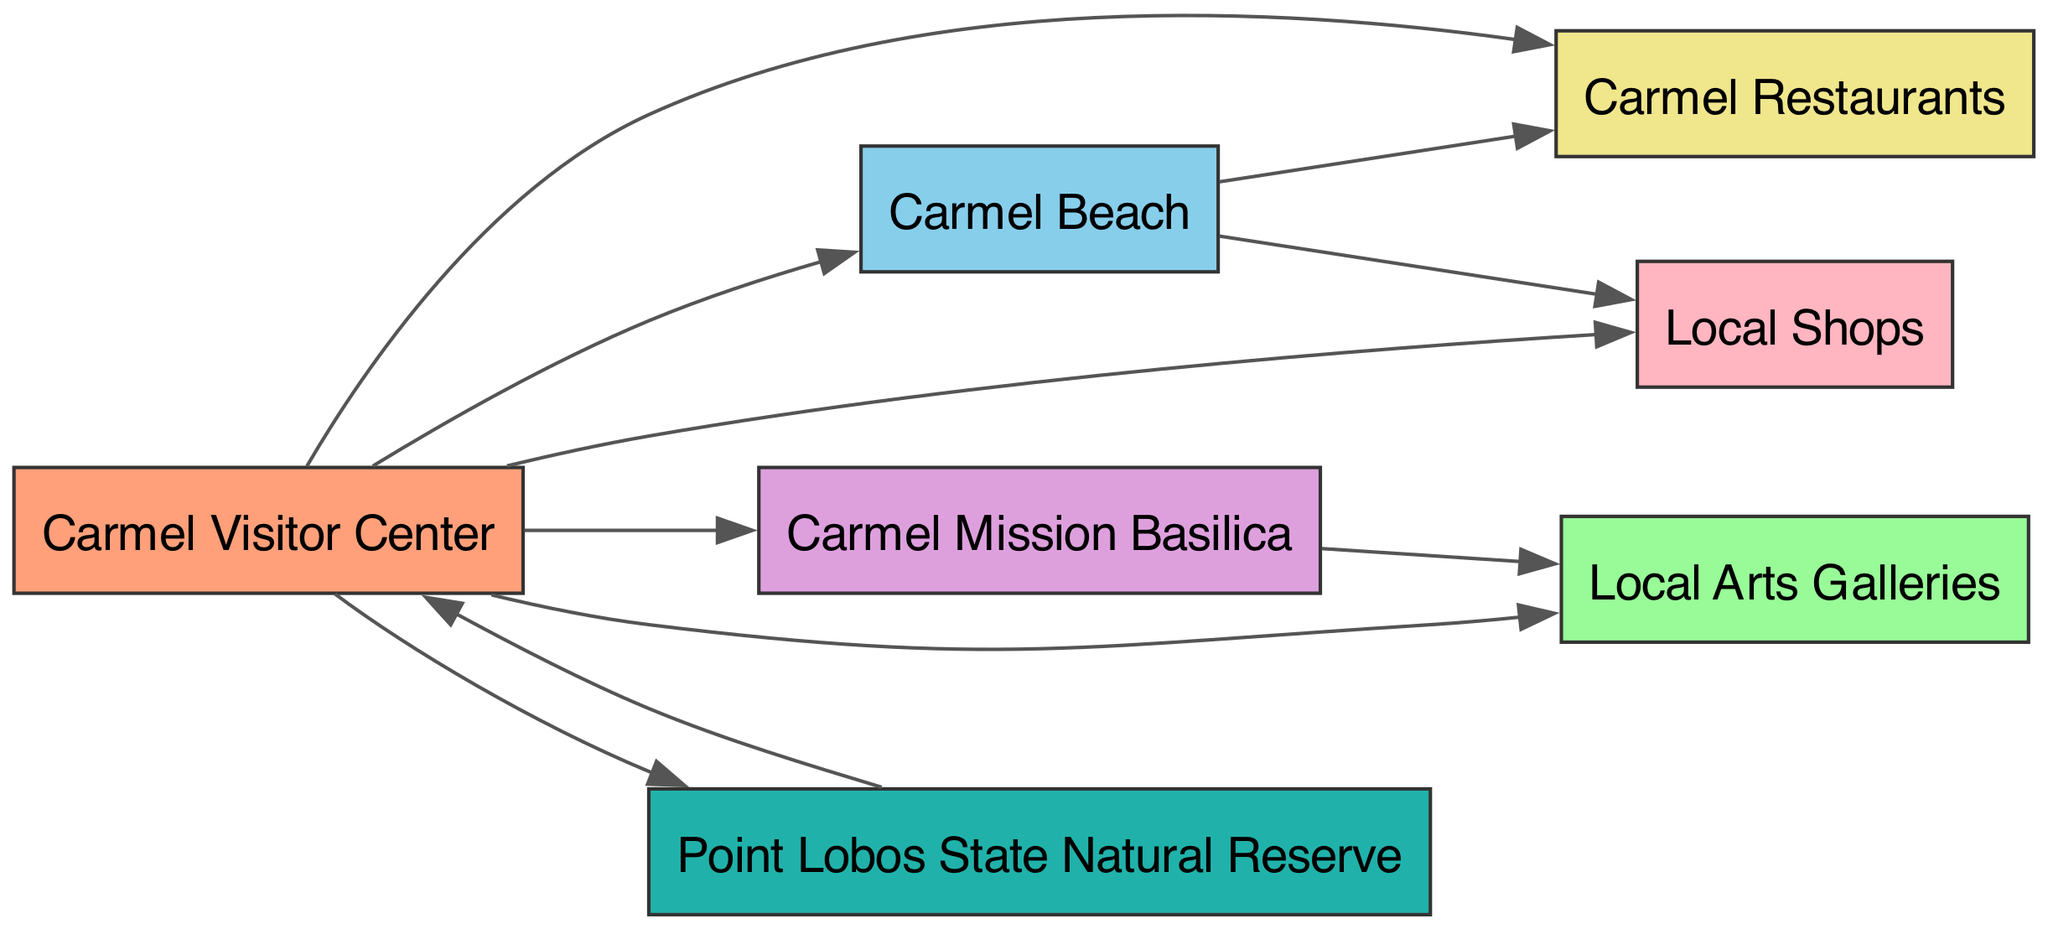What are the total number of nodes in the diagram? The diagram lists a total of 7 nodes: Carmel Visitor Center, Carmel Beach, Carmel Mission Basilica, Local Arts Galleries, Carmel Restaurants, Local Shops, and Point Lobos State Natural Reserve. Thus, counting each unique location leads to a total of 7 nodes.
Answer: 7 Which node has the most outgoing connections? By examining the connections originating from the Carmel Visitor Center, it shows links to all six other nodes: Carmel Beach, Carmel Mission, Arts Galleries, Restaurants, Shops, and Point Lobos State Natural Reserve. Hence, it has the most outgoing connections.
Answer: Carmel Visitor Center What location is connected to both Carmel Beach and Restaurants? Looking at the directed edges from the diagram, Carmel Beach has a direct connection to Restaurants. Hence, it implies that they are interlinked directly through the outlined relationship in the graph.
Answer: Carmel Beach How many edges are present in the diagram? The diagram contains 10 directed edges, which represent the connections between the nodes. By counting each unique connection, we arrive at a total of 10 edges in the diagram.
Answer: 10 Which node has a connection leading back to the Carmel Visitor Center? The Point Lobos State Natural Reserve has a directed edge that points back to the Carmel Visitor Center. This indicates a specific relationship where visitors from Point Lobos can return to the Visitor Center.
Answer: Point Lobos State Natural Reserve Are Arts Galleries connected to any other node? The edges indicate that the Arts Galleries node is connected to two places: Carmel Mission and Carmel Visitor Center. This means that it has outgoing connections to these locations, establishing relationships with them.
Answer: Yes Where can you find both Restaurants and Shops located? By analyzing the edges, both Restaurants and Shops have direct outgoing connections from Carmel Beach. This implies that visitors at Carmel Beach can easily access both these locations.
Answer: Carmel Beach Which node connects the most locations in the diagram? The Carmel Visitor Center is connected to six other nodes: Carmel Beach, Carmel Mission, Arts Galleries, Restaurants, Shops, and Point Lobos State Natural Reserve. This makes it the primary hub linking various locations, connecting the most locations in the diagram.
Answer: Carmel Visitor Center 